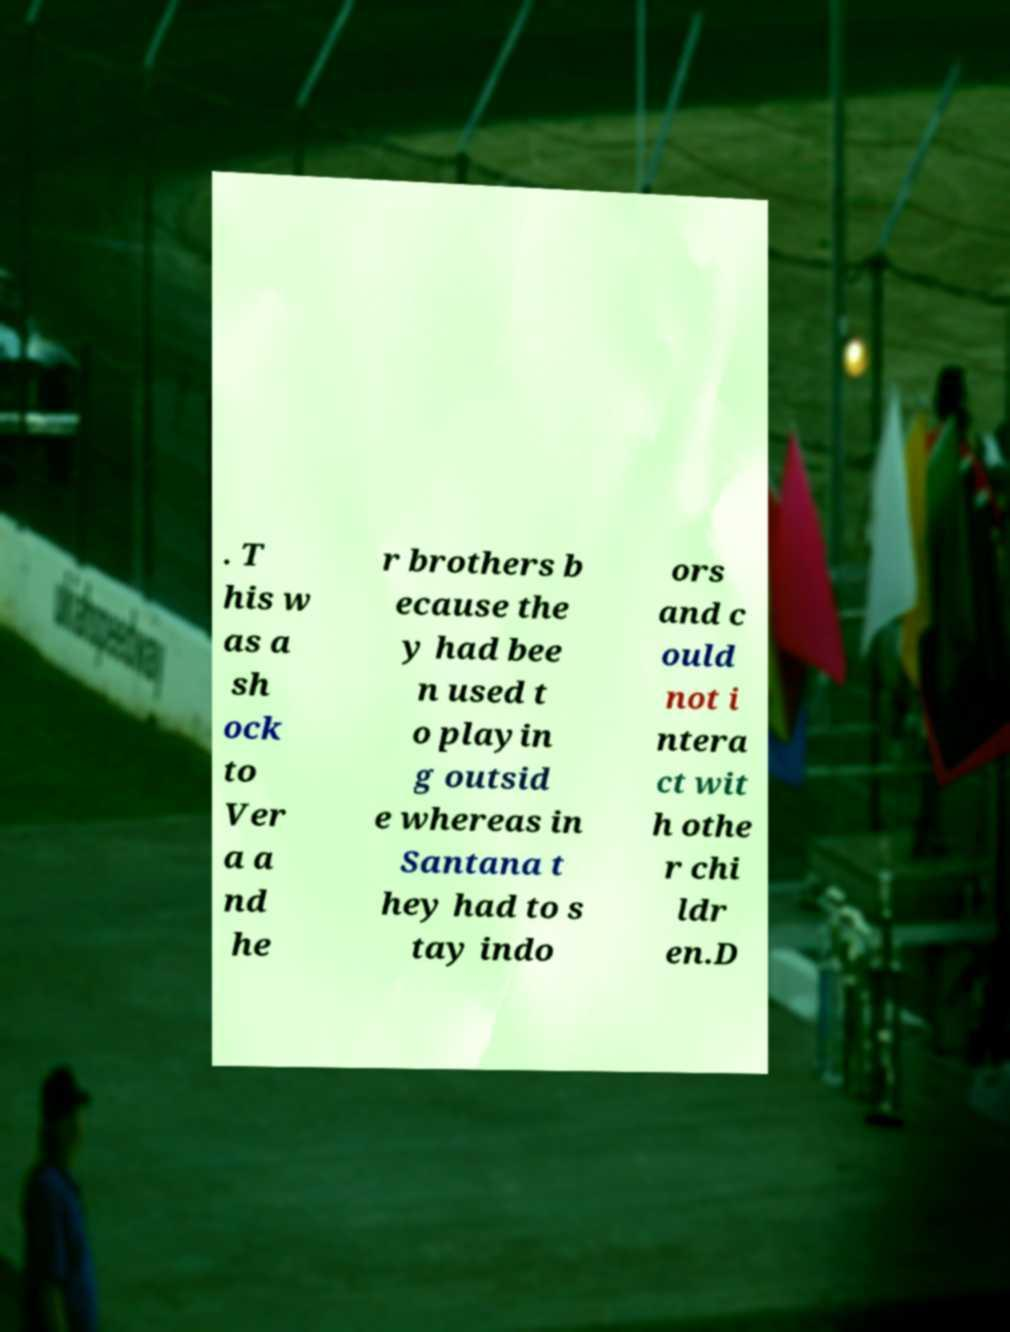Can you accurately transcribe the text from the provided image for me? . T his w as a sh ock to Ver a a nd he r brothers b ecause the y had bee n used t o playin g outsid e whereas in Santana t hey had to s tay indo ors and c ould not i ntera ct wit h othe r chi ldr en.D 